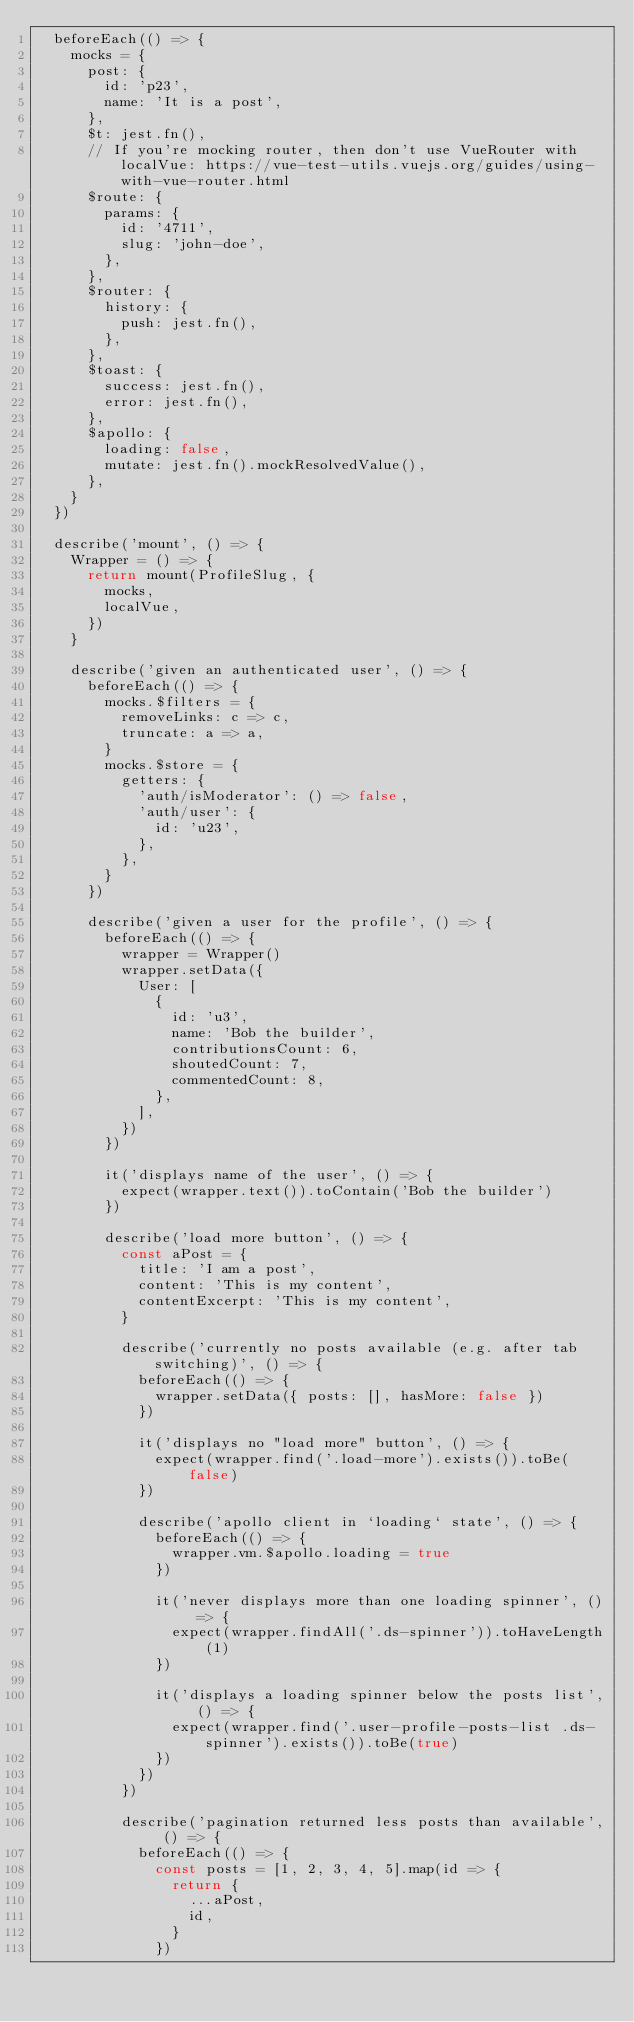Convert code to text. <code><loc_0><loc_0><loc_500><loc_500><_JavaScript_>  beforeEach(() => {
    mocks = {
      post: {
        id: 'p23',
        name: 'It is a post',
      },
      $t: jest.fn(),
      // If you're mocking router, then don't use VueRouter with localVue: https://vue-test-utils.vuejs.org/guides/using-with-vue-router.html
      $route: {
        params: {
          id: '4711',
          slug: 'john-doe',
        },
      },
      $router: {
        history: {
          push: jest.fn(),
        },
      },
      $toast: {
        success: jest.fn(),
        error: jest.fn(),
      },
      $apollo: {
        loading: false,
        mutate: jest.fn().mockResolvedValue(),
      },
    }
  })

  describe('mount', () => {
    Wrapper = () => {
      return mount(ProfileSlug, {
        mocks,
        localVue,
      })
    }

    describe('given an authenticated user', () => {
      beforeEach(() => {
        mocks.$filters = {
          removeLinks: c => c,
          truncate: a => a,
        }
        mocks.$store = {
          getters: {
            'auth/isModerator': () => false,
            'auth/user': {
              id: 'u23',
            },
          },
        }
      })

      describe('given a user for the profile', () => {
        beforeEach(() => {
          wrapper = Wrapper()
          wrapper.setData({
            User: [
              {
                id: 'u3',
                name: 'Bob the builder',
                contributionsCount: 6,
                shoutedCount: 7,
                commentedCount: 8,
              },
            ],
          })
        })

        it('displays name of the user', () => {
          expect(wrapper.text()).toContain('Bob the builder')
        })

        describe('load more button', () => {
          const aPost = {
            title: 'I am a post',
            content: 'This is my content',
            contentExcerpt: 'This is my content',
          }

          describe('currently no posts available (e.g. after tab switching)', () => {
            beforeEach(() => {
              wrapper.setData({ posts: [], hasMore: false })
            })

            it('displays no "load more" button', () => {
              expect(wrapper.find('.load-more').exists()).toBe(false)
            })

            describe('apollo client in `loading` state', () => {
              beforeEach(() => {
                wrapper.vm.$apollo.loading = true
              })

              it('never displays more than one loading spinner', () => {
                expect(wrapper.findAll('.ds-spinner')).toHaveLength(1)
              })

              it('displays a loading spinner below the posts list', () => {
                expect(wrapper.find('.user-profile-posts-list .ds-spinner').exists()).toBe(true)
              })
            })
          })

          describe('pagination returned less posts than available', () => {
            beforeEach(() => {
              const posts = [1, 2, 3, 4, 5].map(id => {
                return {
                  ...aPost,
                  id,
                }
              })
</code> 